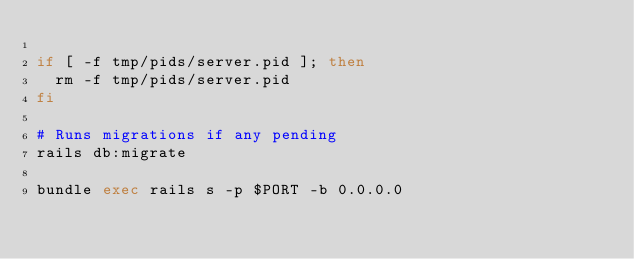Convert code to text. <code><loc_0><loc_0><loc_500><loc_500><_Bash_>
if [ -f tmp/pids/server.pid ]; then
  rm -f tmp/pids/server.pid
fi

# Runs migrations if any pending
rails db:migrate

bundle exec rails s -p $PORT -b 0.0.0.0
</code> 